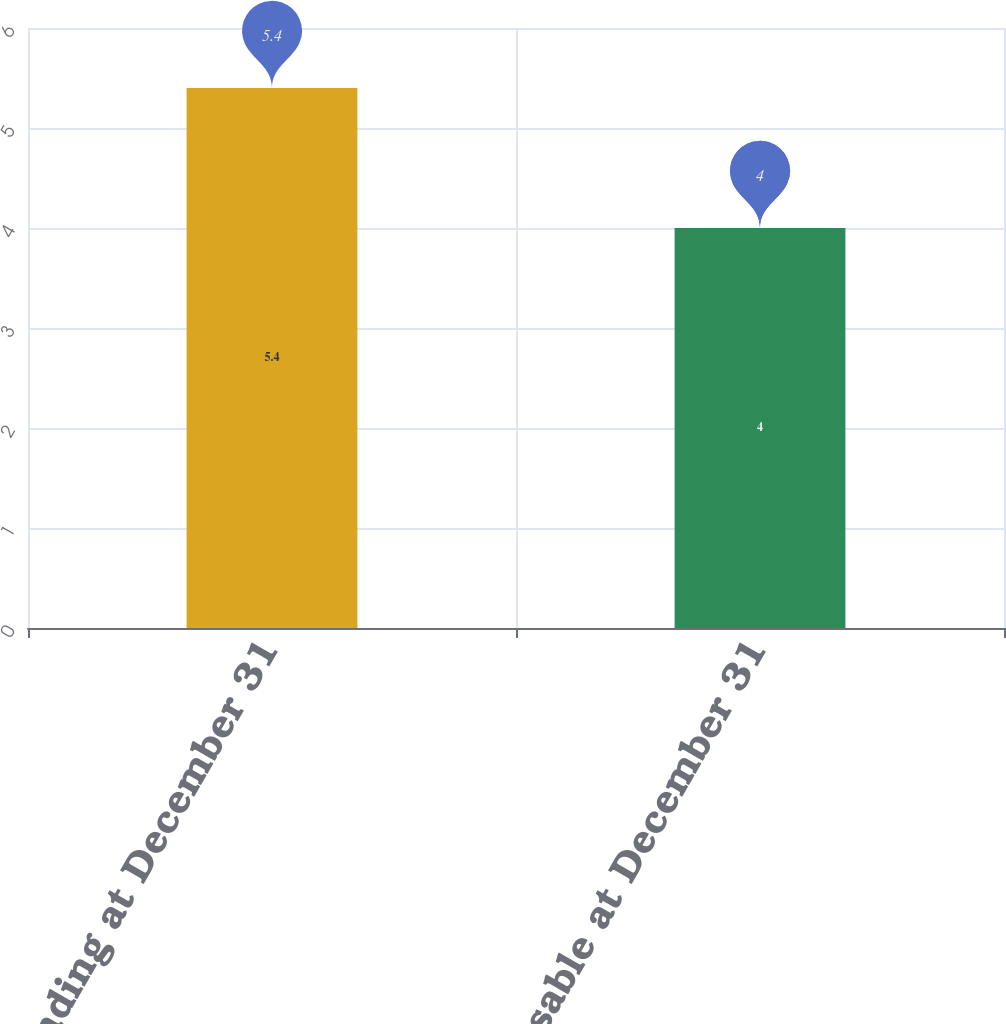Convert chart. <chart><loc_0><loc_0><loc_500><loc_500><bar_chart><fcel>Outstanding at December 31<fcel>Exercisable at December 31<nl><fcel>5.4<fcel>4<nl></chart> 